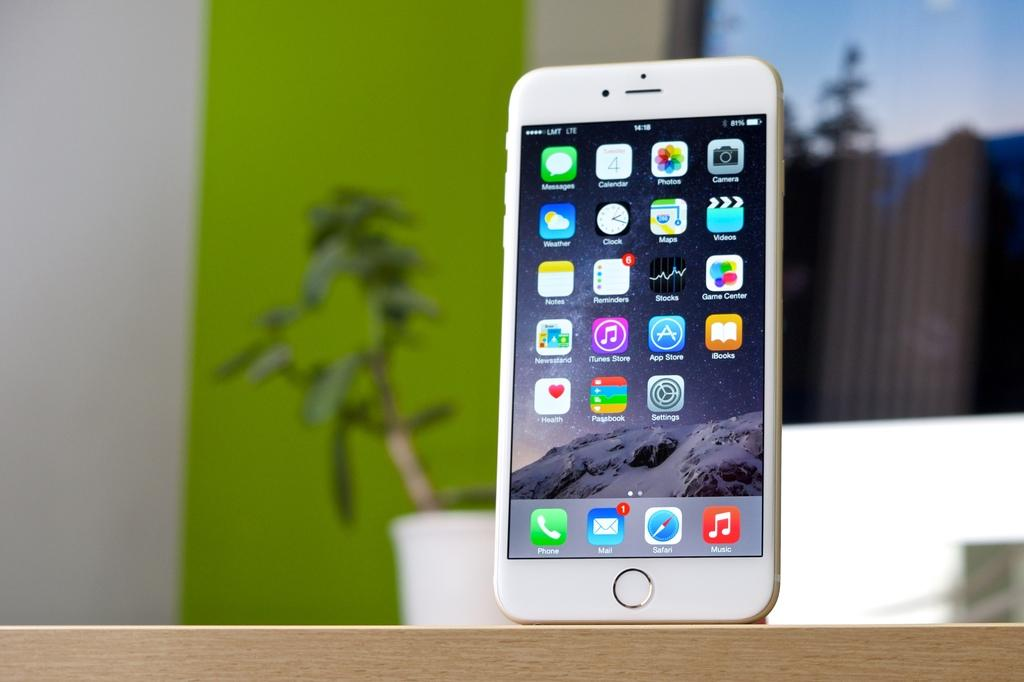What can be seen hanging in the image? There is a mobile in the image. What object is located at the bottom of the image? There is a wooden block at the bottom of the image. What type of plant is visible in the background of the image? There is a houseplant in the background of the image. What surface is visible in the background of the image? There is a screen and a wall in the background of the image. What color is the sock that is sparking on the wall in the image? There is no sock or sparking in the image; it only features a mobile, a wooden block, a houseplant, a screen, and a wall. 